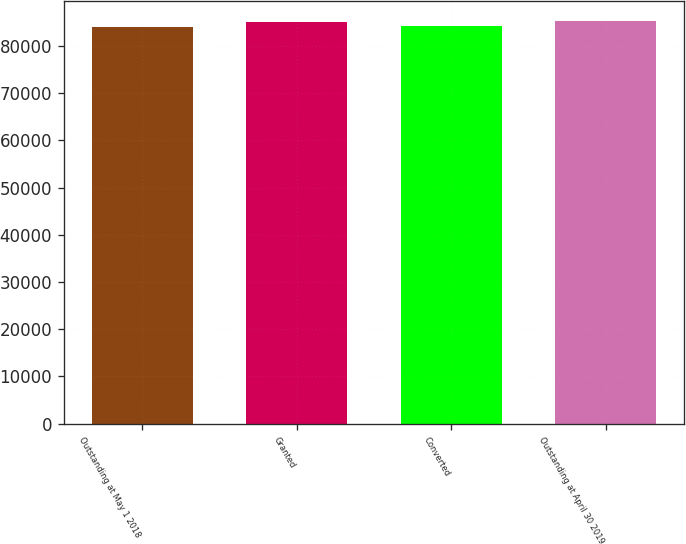<chart> <loc_0><loc_0><loc_500><loc_500><bar_chart><fcel>Outstanding at May 1 2018<fcel>Granted<fcel>Converted<fcel>Outstanding at April 30 2019<nl><fcel>84051<fcel>85154<fcel>84161.3<fcel>85264.3<nl></chart> 